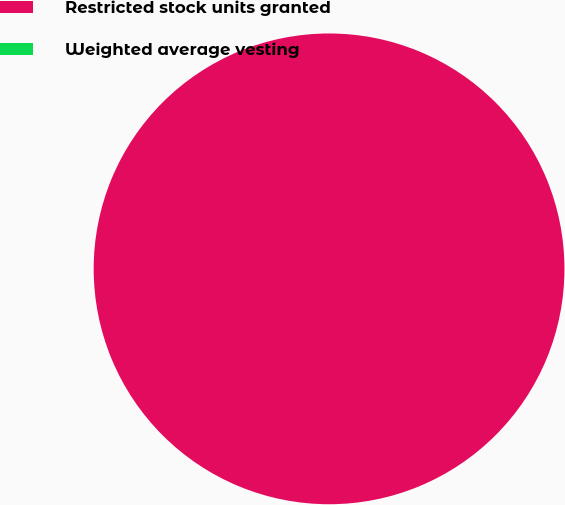Convert chart. <chart><loc_0><loc_0><loc_500><loc_500><pie_chart><fcel>Restricted stock units granted<fcel>Weighted average vesting<nl><fcel>100.0%<fcel>0.0%<nl></chart> 